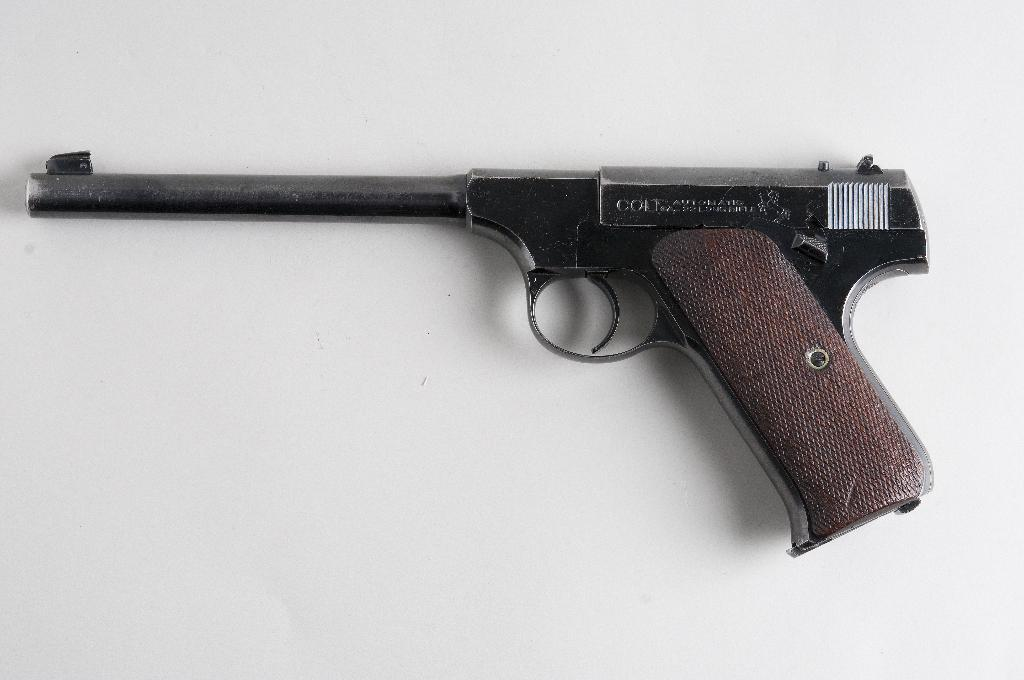What object is present on the table in the image? There is a pistol on the table in the image. Can you describe the location of the pistol in the image? The pistol is kept on a table in the image. How many spiders are crawling on the pistol in the image? There are no spiders present in the image; it only features a pistol on a table. 